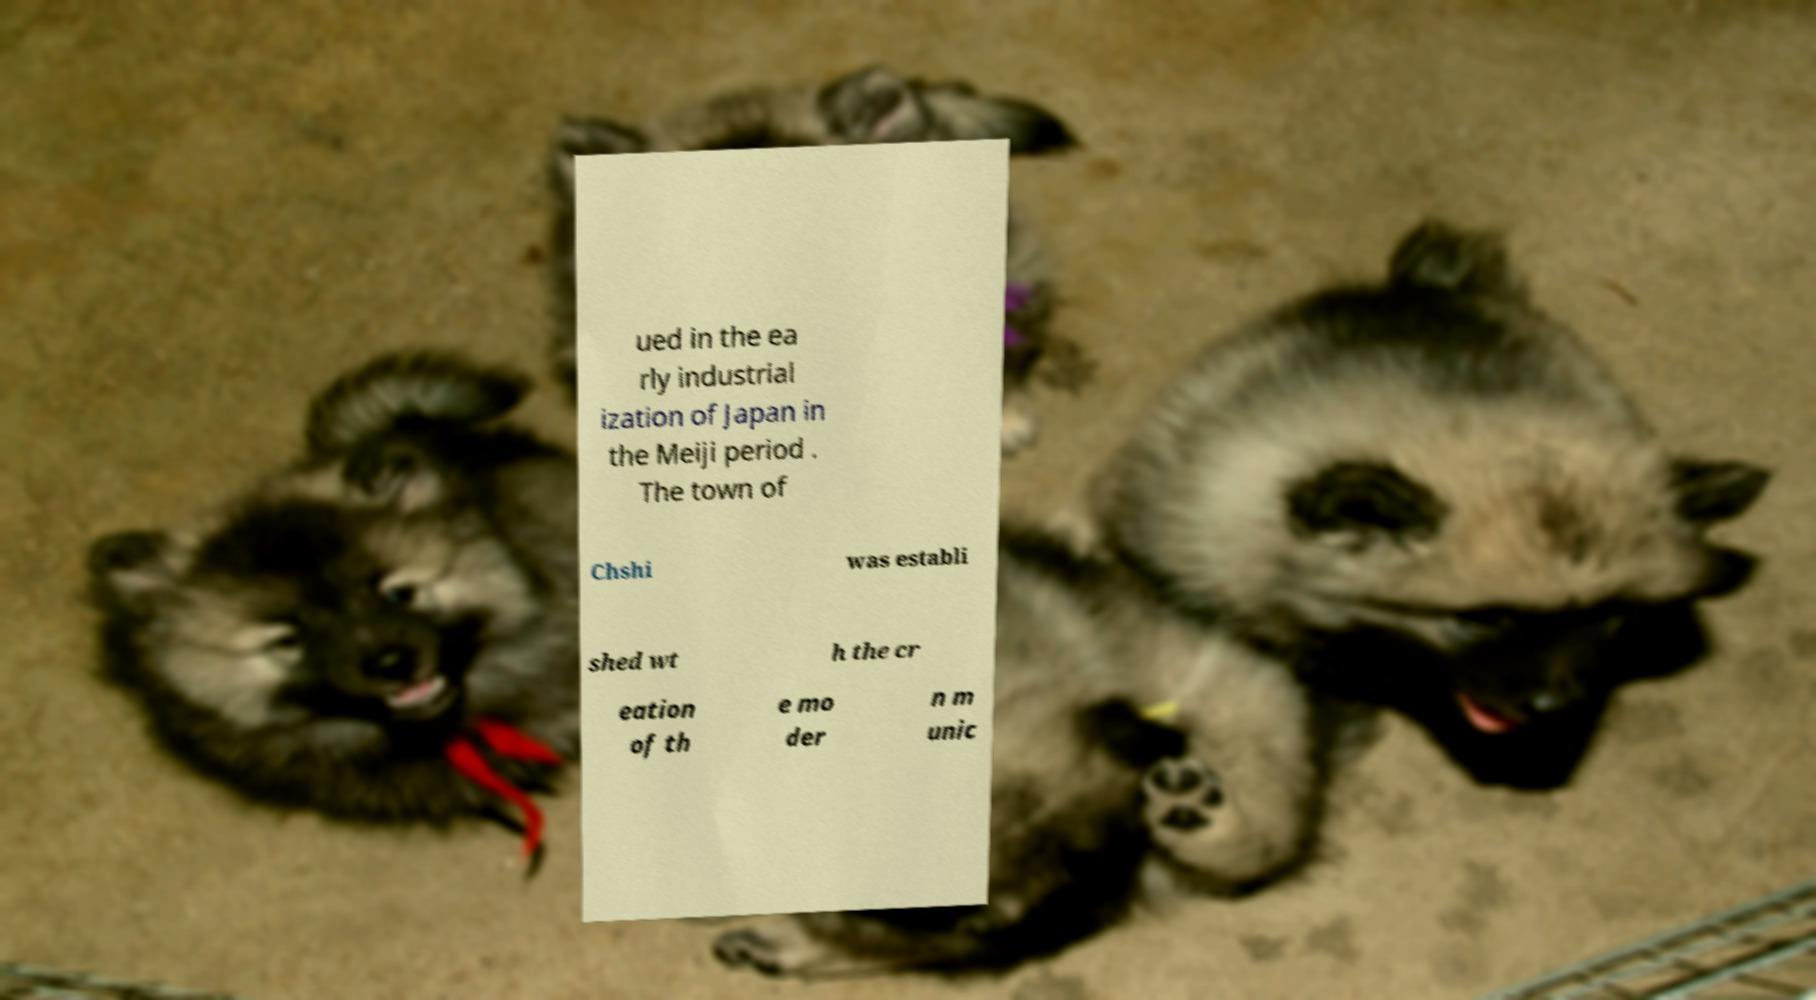What messages or text are displayed in this image? I need them in a readable, typed format. ued in the ea rly industrial ization of Japan in the Meiji period . The town of Chshi was establi shed wt h the cr eation of th e mo der n m unic 